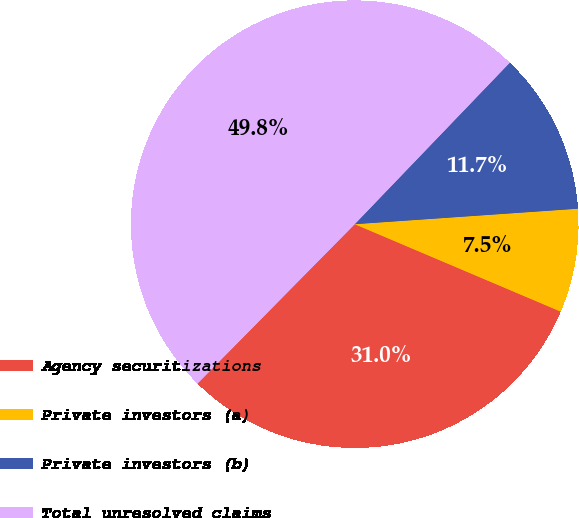<chart> <loc_0><loc_0><loc_500><loc_500><pie_chart><fcel>Agency securitizations<fcel>Private investors (a)<fcel>Private investors (b)<fcel>Total unresolved claims<nl><fcel>31.0%<fcel>7.49%<fcel>11.72%<fcel>49.78%<nl></chart> 